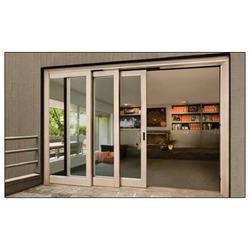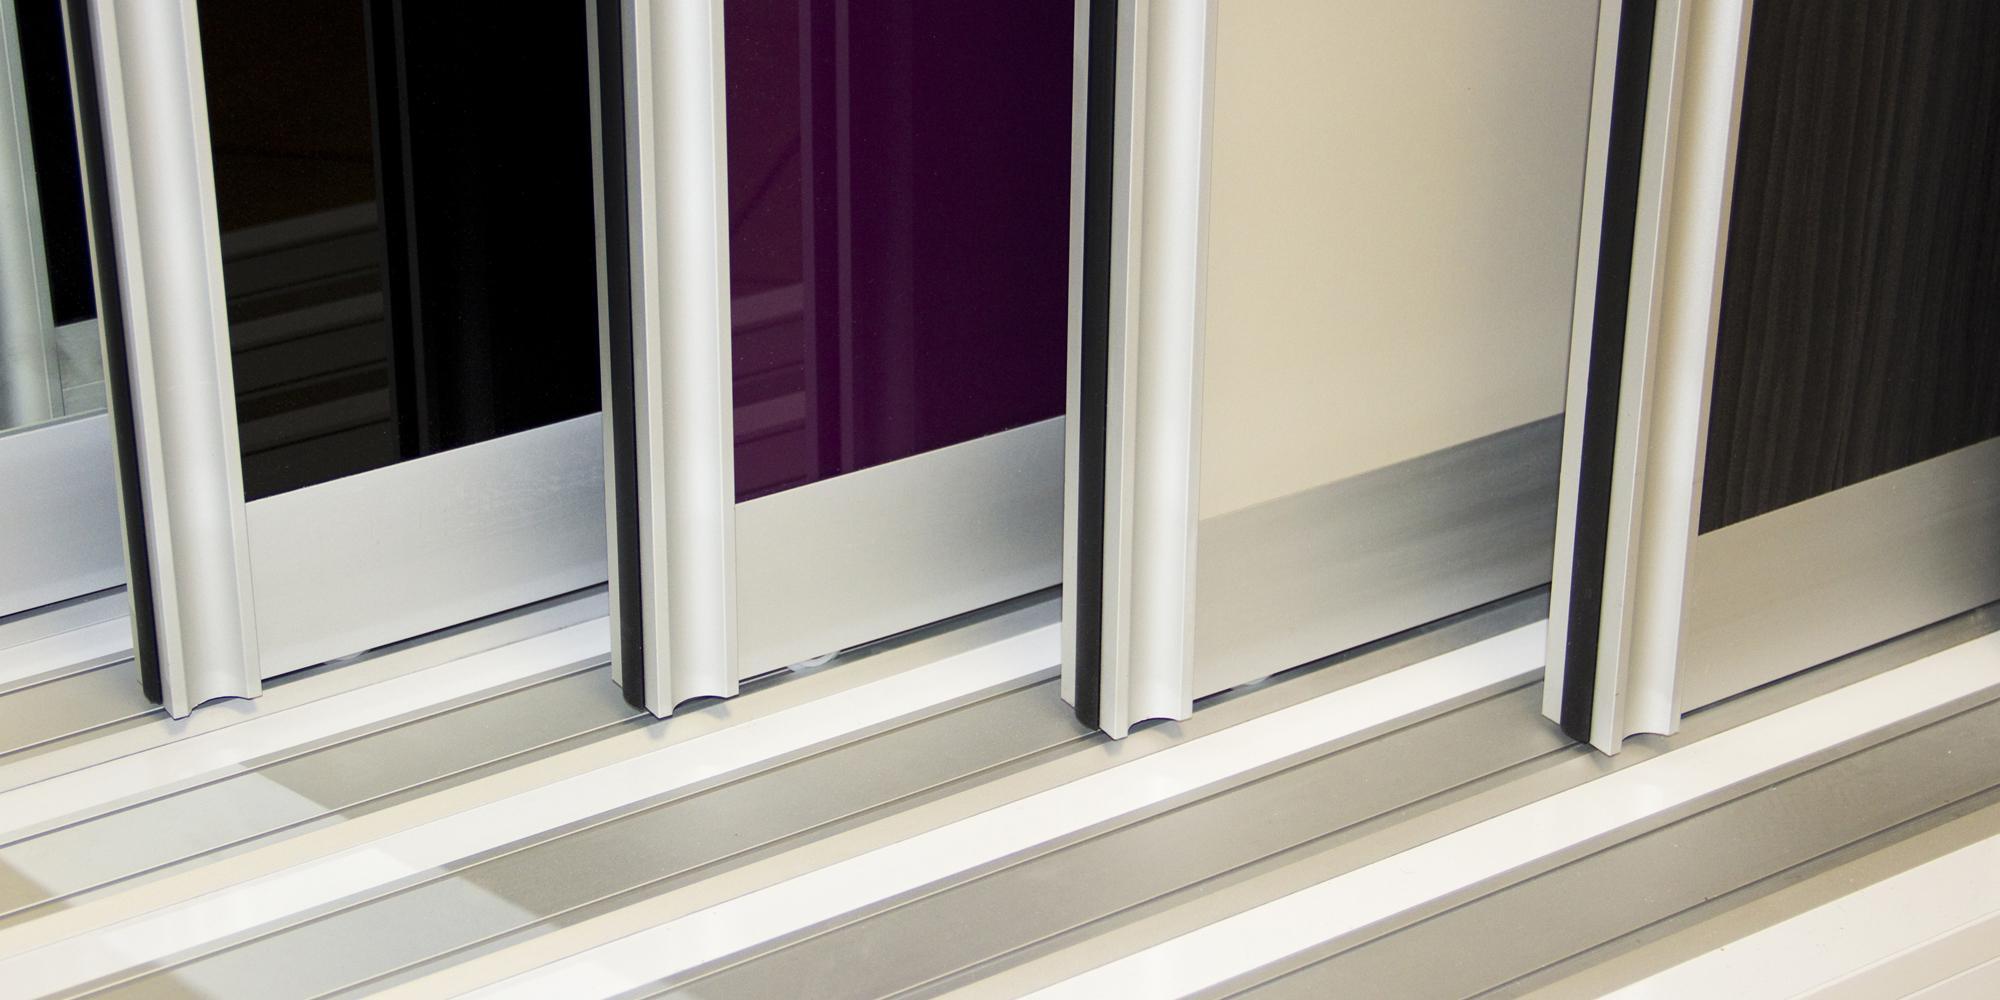The first image is the image on the left, the second image is the image on the right. Examine the images to the left and right. Is the description "The metal framed door in the image on the right is opened just a bit." accurate? Answer yes or no. No. The first image is the image on the left, the second image is the image on the right. Analyze the images presented: Is the assertion "An image shows tracks and three sliding glass doors with dark frames." valid? Answer yes or no. No. 